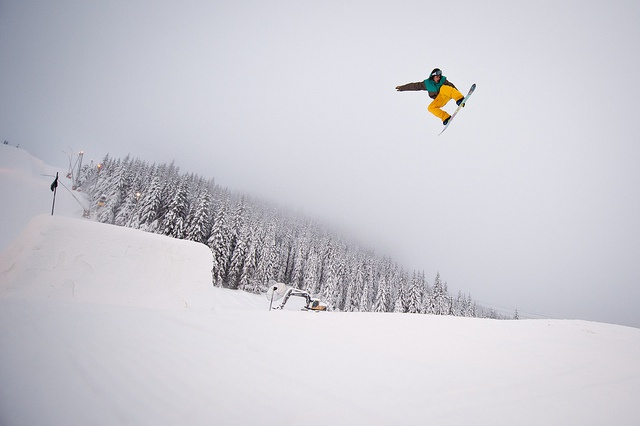Describe the objects in this image and their specific colors. I can see people in gray, orange, black, teal, and maroon tones, snowboard in gray, darkgray, lightgray, and lightblue tones, people in gray and darkgray tones, and people in gray tones in this image. 